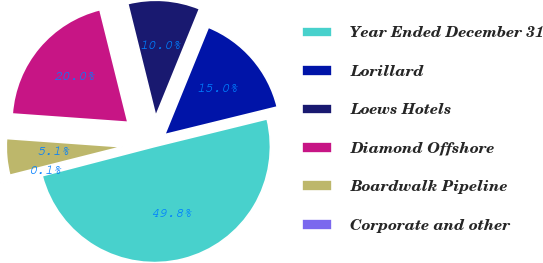Convert chart. <chart><loc_0><loc_0><loc_500><loc_500><pie_chart><fcel>Year Ended December 31<fcel>Lorillard<fcel>Loews Hotels<fcel>Diamond Offshore<fcel>Boardwalk Pipeline<fcel>Corporate and other<nl><fcel>49.78%<fcel>15.01%<fcel>10.04%<fcel>19.98%<fcel>5.08%<fcel>0.11%<nl></chart> 